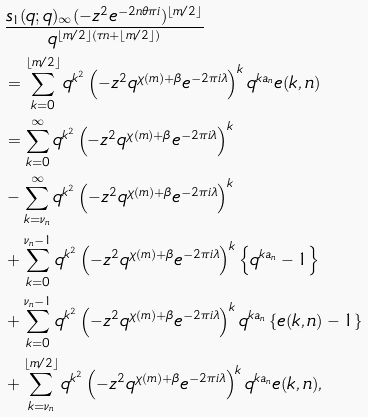Convert formula to latex. <formula><loc_0><loc_0><loc_500><loc_500>& \frac { s _ { 1 } ( q ; q ) _ { \infty } ( - z ^ { 2 } e ^ { - 2 n \theta \pi i } ) ^ { \left \lfloor m / 2 \right \rfloor } } { q ^ { \left \lfloor m / 2 \right \rfloor ( \tau n + \left \lfloor m / 2 \right \rfloor ) } } \\ & = \sum _ { k = 0 } ^ { \left \lfloor m / 2 \right \rfloor } q ^ { k ^ { 2 } } \left ( - z ^ { 2 } q ^ { \chi ( m ) + \beta } e ^ { - 2 \pi i \lambda } \right ) ^ { k } q ^ { k a _ { n } } e ( k , n ) \\ & = \sum _ { k = 0 } ^ { \infty } q ^ { k ^ { 2 } } \left ( - z ^ { 2 } q ^ { \chi ( m ) + \beta } e ^ { - 2 \pi i \lambda } \right ) ^ { k } \\ & - \sum _ { k = \nu _ { n } } ^ { \infty } q ^ { k ^ { 2 } } \left ( - z ^ { 2 } q ^ { \chi ( m ) + \beta } e ^ { - 2 \pi i \lambda } \right ) ^ { k } \\ & + \sum _ { k = 0 } ^ { \nu _ { n } - 1 } q ^ { k ^ { 2 } } \left ( - z ^ { 2 } q ^ { \chi ( m ) + \beta } e ^ { - 2 \pi i \lambda } \right ) ^ { k } \left \{ q ^ { k a _ { n } } - 1 \right \} \\ & + \sum _ { k = 0 } ^ { \nu _ { n } - 1 } q ^ { k ^ { 2 } } \left ( - z ^ { 2 } q ^ { \chi ( m ) + \beta } e ^ { - 2 \pi i \lambda } \right ) ^ { k } q ^ { k a _ { n } } \left \{ e ( k , n ) - 1 \right \} \\ & + \sum _ { k = \nu _ { n } } ^ { \left \lfloor m / 2 \right \rfloor } q ^ { k ^ { 2 } } \left ( - z ^ { 2 } q ^ { \chi ( m ) + \beta } e ^ { - 2 \pi i \lambda } \right ) ^ { k } q ^ { k a _ { n } } e ( k , n ) ,</formula> 